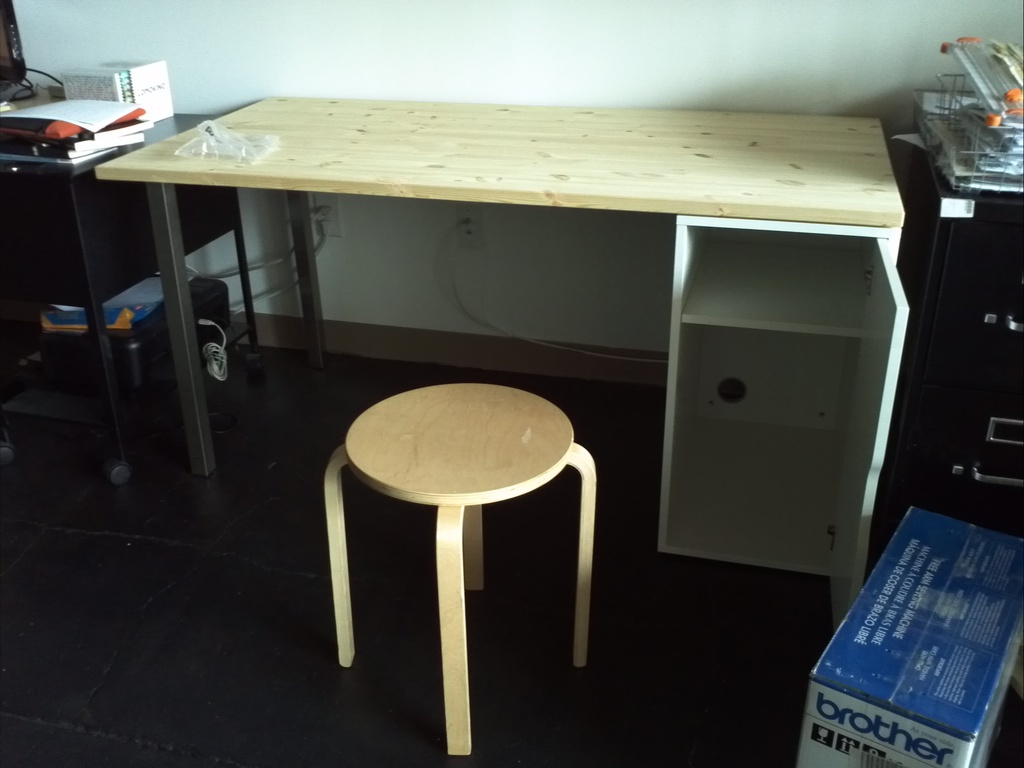What can be inferred about the function of this room? The room appears to serve as an office space given the presence of the desk, the utilitarian stool, and various office supplies, although the overall sparse decoration hints at a possibly new and not yet fully furnished office. Is there anything noteworthy about the organization of the room? The room's organization emphasizes simplicity and functionality with clean lines and minimal furnishings, which might indicate a preference for an uncluttered and focused work environment. 